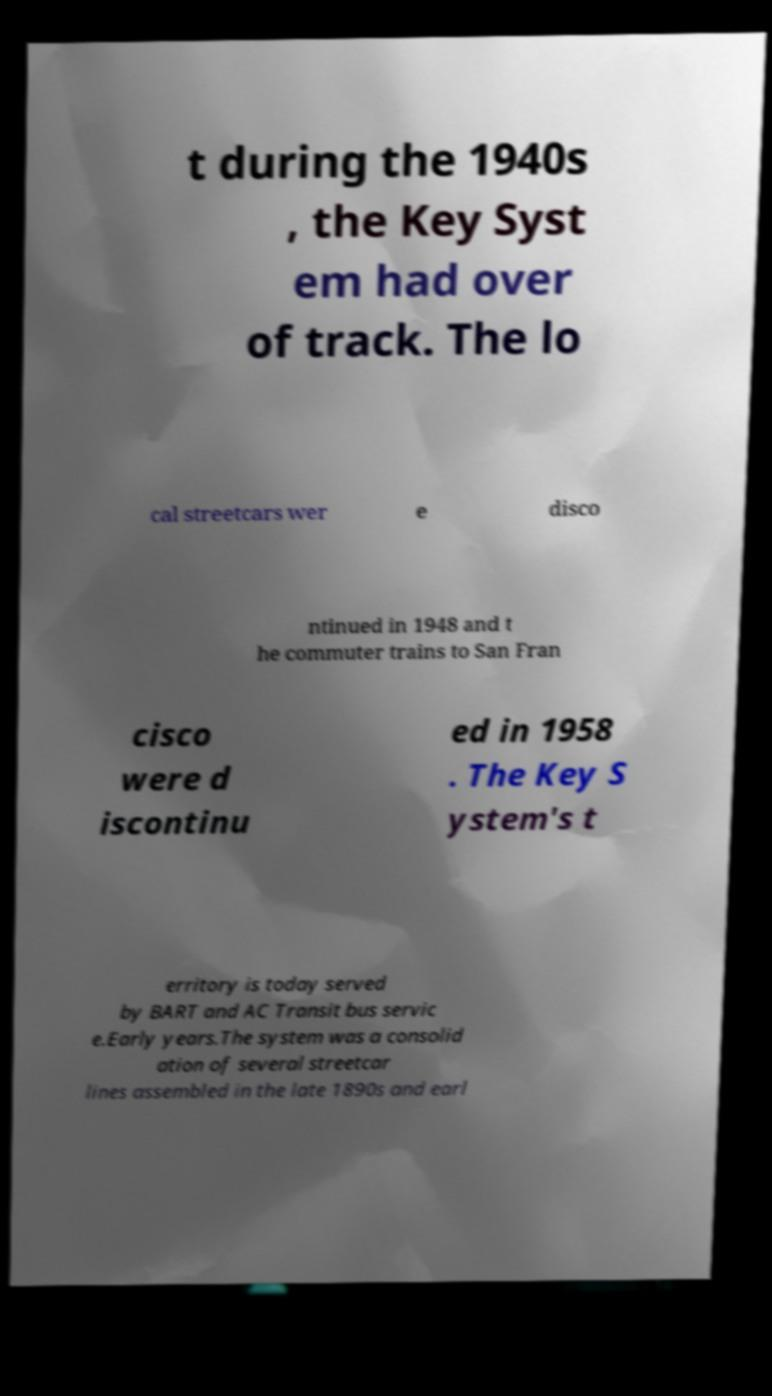Can you accurately transcribe the text from the provided image for me? t during the 1940s , the Key Syst em had over of track. The lo cal streetcars wer e disco ntinued in 1948 and t he commuter trains to San Fran cisco were d iscontinu ed in 1958 . The Key S ystem's t erritory is today served by BART and AC Transit bus servic e.Early years.The system was a consolid ation of several streetcar lines assembled in the late 1890s and earl 